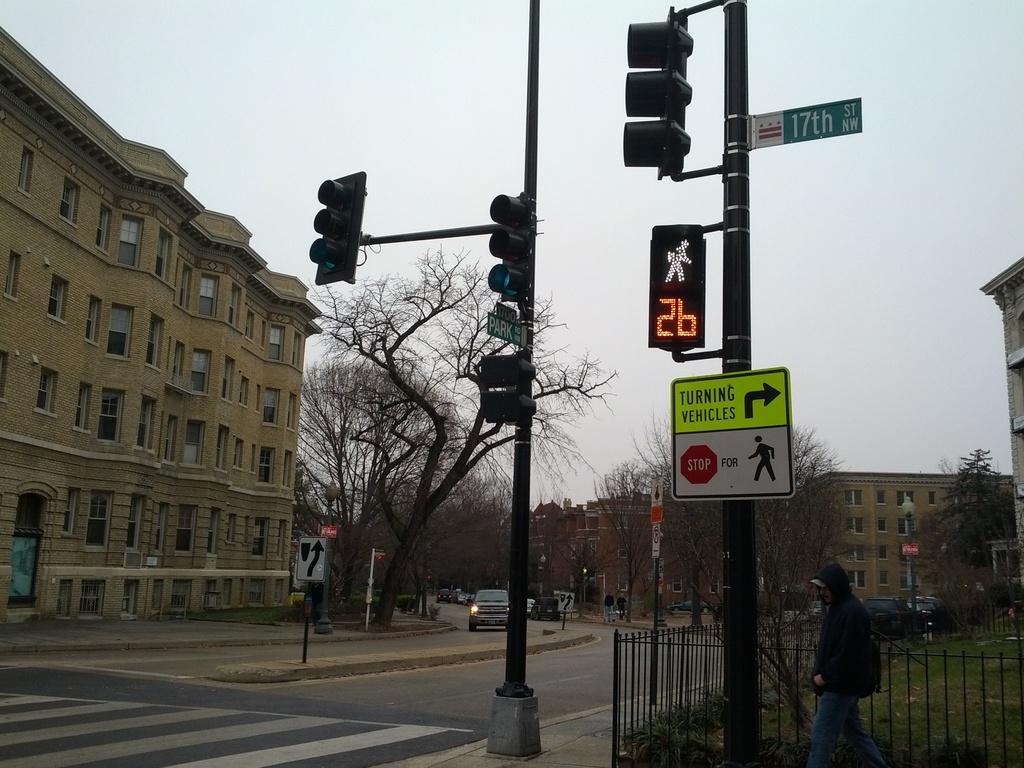In one or two sentences, can you explain what this image depicts? In the image we can see the buildings and these are the windows of the buildings. Here we can see the signal poles and sign boards. Here we can see the fence and the trees. We can even see there are people and there are vehicles on the road, and the sky. 